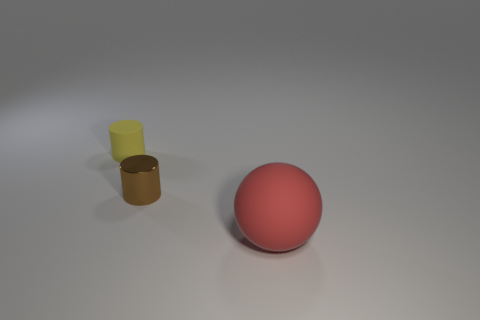Which object in the image is the largest? The red sphere is the largest object in the image. 